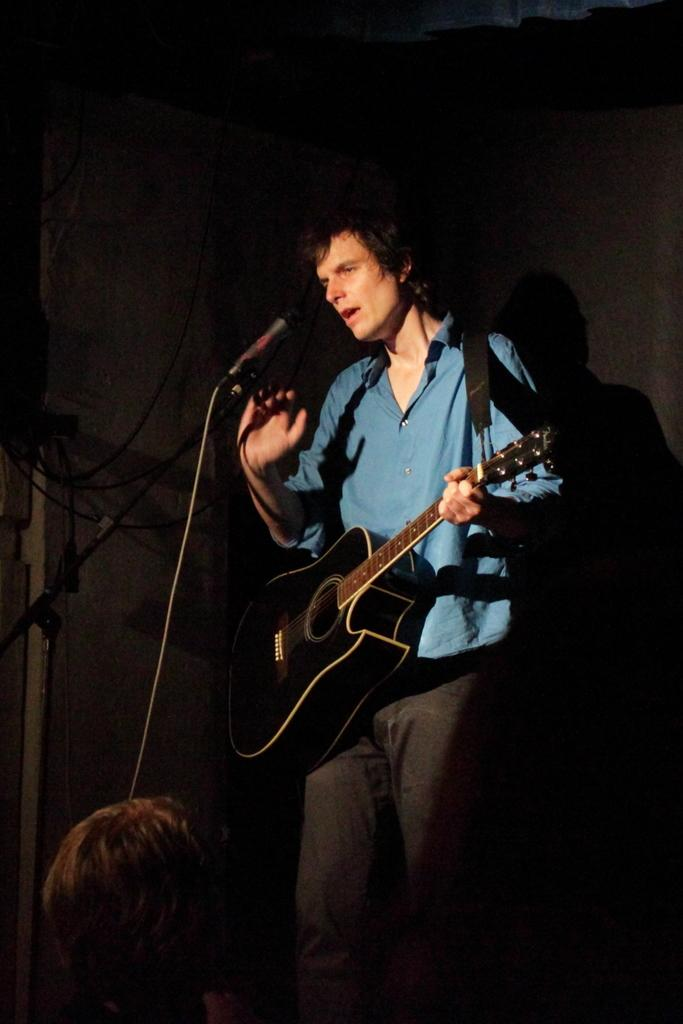What is the main subject of the image? The main subject of the image is a man. What is the man doing in the image? The man is standing, holding a guitar, and singing into a microphone. Can you describe the people in the background of the image? There is a group of persons in the background of the image. What is the color of the background in the image? The background of the image is dark. What type of ship can be seen in the image? There is no ship present in the image. How many pigs are visible in the image? There are no pigs visible in the image. 